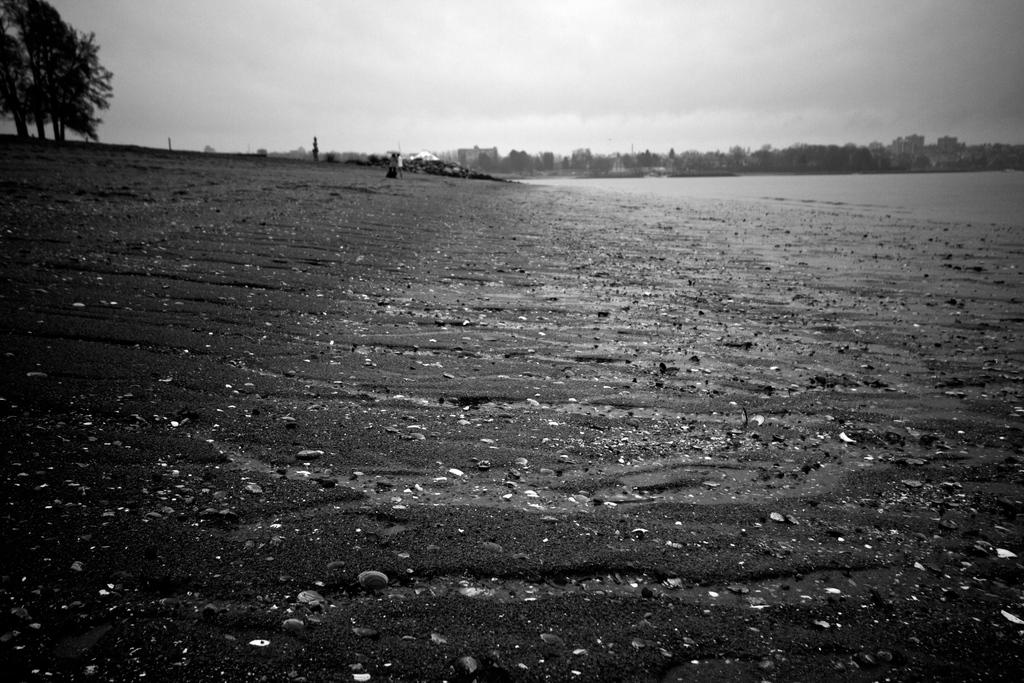What is the color scheme of the image? The image is black and white. What type of natural elements can be seen in the image? There are trees in the image. What type of man-made structures are present in the image? There are buildings in the image. What is visible in the background of the image? The sky is visible in the background of the image. What type of stove is visible in the image? There is no stove present in the image. What is the occupation of the thing in the image? The question is unclear and does not make sense in the context of the image, as there is no "thing" mentioned in the facts. 